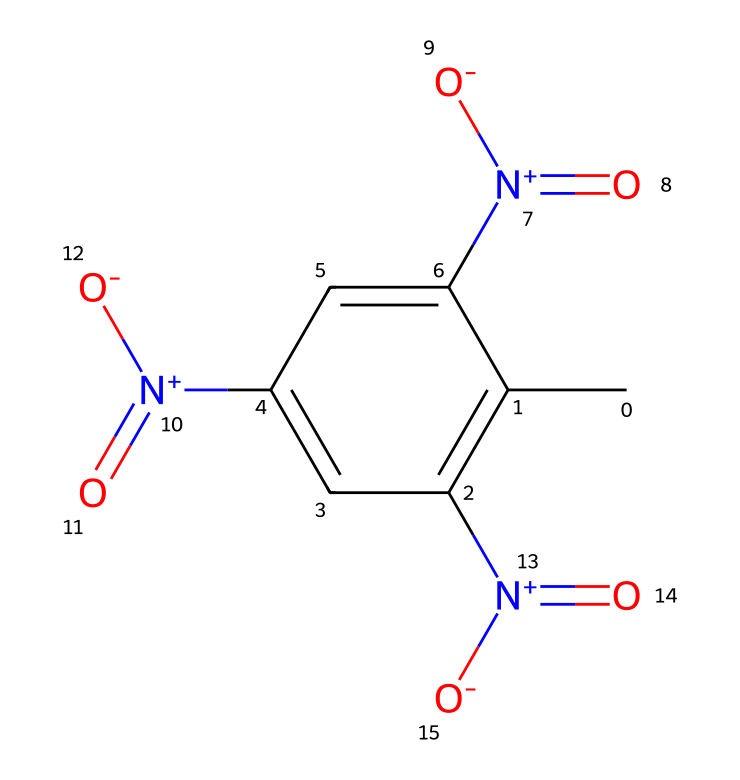What is the molecular formula of this compound? To derive the molecular formula from the SMILES representation, count the carbon (C), hydrogen (H), nitrogen (N), and oxygen (O) atoms present. The counts yield C7, H5, N3, and O6, leading to the molecular formula C7H5N3O6.
Answer: C7H5N3O6 How many nitrogen atoms are present in the structure? By inspecting the SMILES notation, note that there are three occurrences of the nitrogen atom (N), indicated by [N+](=O)[O-] which represents nitro groups. Thus, the total count equals three.
Answer: 3 What type of chemical reaction is TNT primarily associated with? TNT is mainly known for undergoing an explosive decomposition reaction when detonated. This type of explosive behavior is characteristic of nitro compounds, which release large amounts of gases and heat.
Answer: explosion Identify the functional groups present in the compound. By examining the SMILES, the presence of the nitro groups [N+](=O)[O-] indicates that the compound has nitro functional groups. Additionally, the benzene-like structure shows it is aromatic. The presence of both types identifies it specifically as an aromatic nitro compound.
Answer: nitro group What is the characteristic structural feature of TNT that contributes to its stability? The stability of TNT is primarily attributed to its aromatic ring structure, which provides resonance stabilization. This characteristic makes it less sensitive to shock and heat while still enabling rapid decomposition upon detonation.
Answer: aromatic ring 